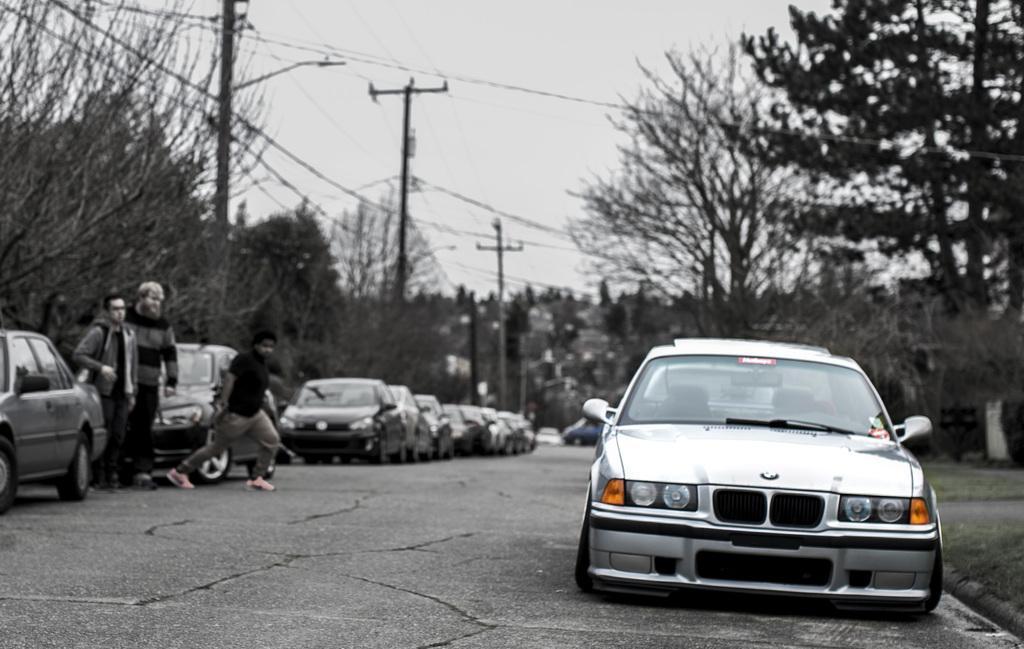How would you summarize this image in a sentence or two? In this image we can see few cars on the road, three persons standing near the cars and there are few trees, poles with wires and the sky in the background. 